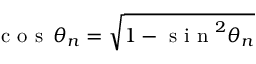<formula> <loc_0><loc_0><loc_500><loc_500>c o s \, \theta _ { n } = \sqrt { 1 - s i n ^ { 2 } \theta _ { n } }</formula> 